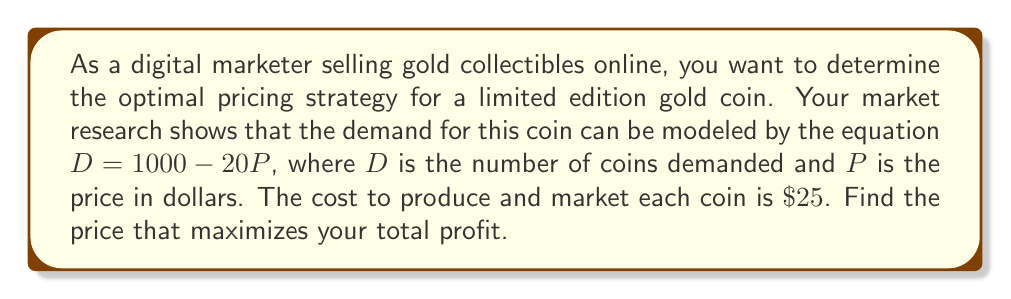Can you solve this math problem? To solve this problem, we'll follow these steps:

1. Define the revenue function:
   Revenue = Price × Quantity
   $R = P \times D = P(1000 - 20P) = 1000P - 20P^2$

2. Define the cost function:
   Cost = Fixed Cost + Variable Cost × Quantity
   $C = 0 + 25(1000 - 20P) = 25000 - 500P$

3. Define the profit function:
   Profit = Revenue - Cost
   $\Pi = R - C = (1000P - 20P^2) - (25000 - 500P)$
   $\Pi = 1000P - 20P^2 - 25000 + 500P$
   $\Pi = 1500P - 20P^2 - 25000$

4. To find the maximum profit, we need to find the vertex of this quadratic function. We can do this by finding where the derivative equals zero:
   $\frac{d\Pi}{dP} = 1500 - 40P$
   Set this equal to zero and solve for P:
   $1500 - 40P = 0$
   $40P = 1500$
   $P = \frac{1500}{40} = 37.5$

5. Verify this is a maximum by checking the second derivative:
   $\frac{d^2\Pi}{dP^2} = -40$, which is negative, confirming a maximum.

Therefore, the optimal price to maximize profit is $\$37.50$ per coin.
Answer: The optimal price to maximize profit is $\$37.50$ per gold collectible coin. 